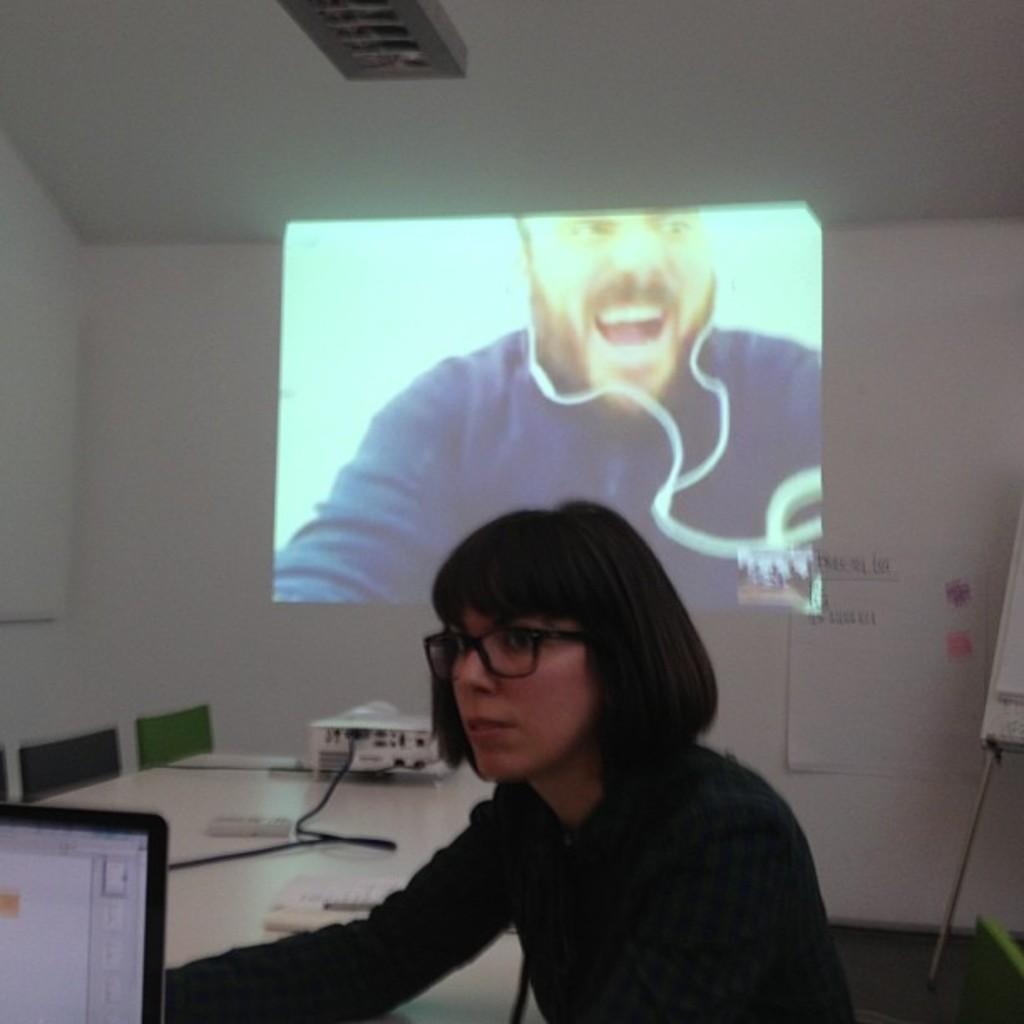Can you describe this image briefly? A woman is looking at the left side, she wore spectacles. In the middle it is a projected image, in that a man is there, he wore ear phones. 